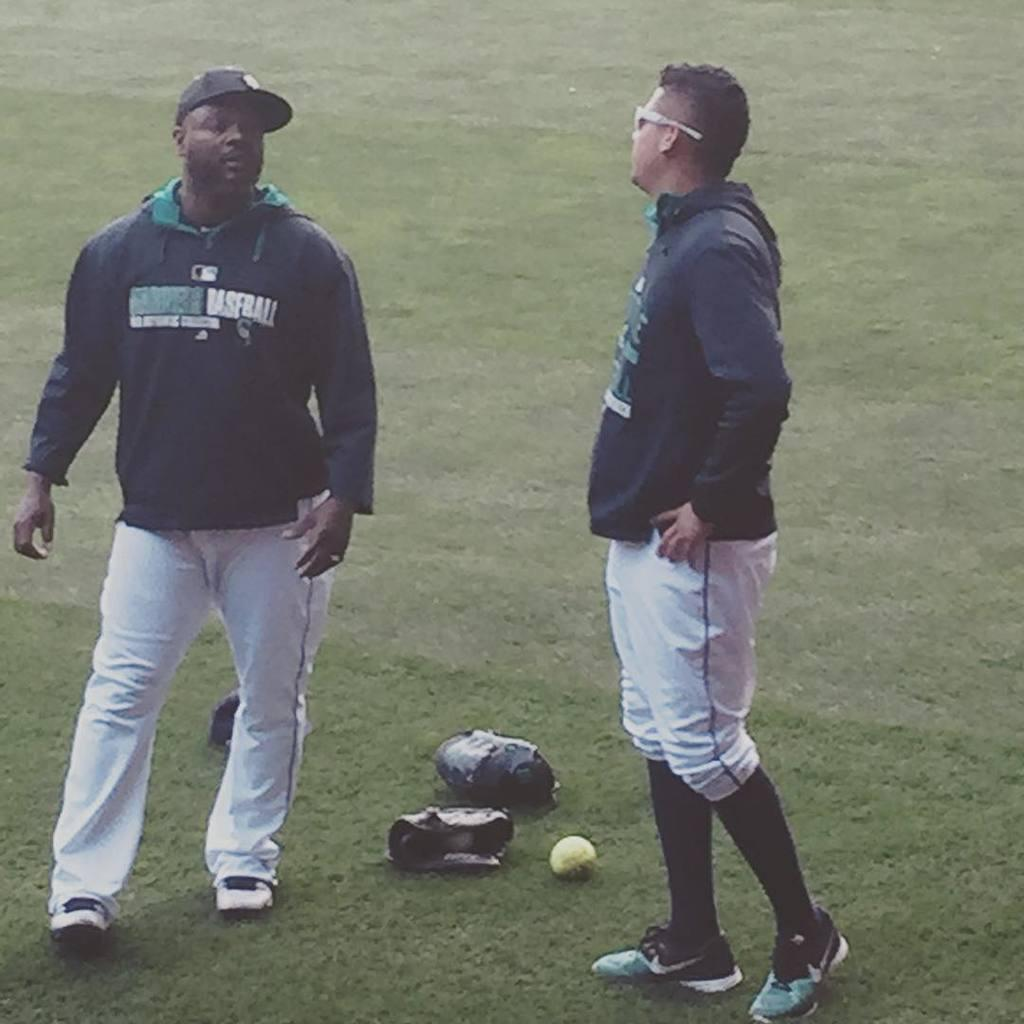<image>
Relay a brief, clear account of the picture shown. Two men stand on a baseball field wearing sweatshirts that say BASEBALL 